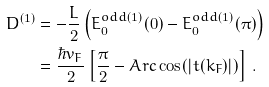Convert formula to latex. <formula><loc_0><loc_0><loc_500><loc_500>D ^ { ( 1 ) } & = - \frac { L } { 2 } \left ( E _ { 0 } ^ { o d d ( 1 ) } ( 0 ) - E _ { 0 } ^ { o d d ( 1 ) } ( \pi ) \right ) \\ & = \frac { \hbar { v } _ { F } } { 2 } \left [ \frac { \pi } { 2 } - A r c \cos ( | t ( k _ { F } ) | ) \right ] \, .</formula> 